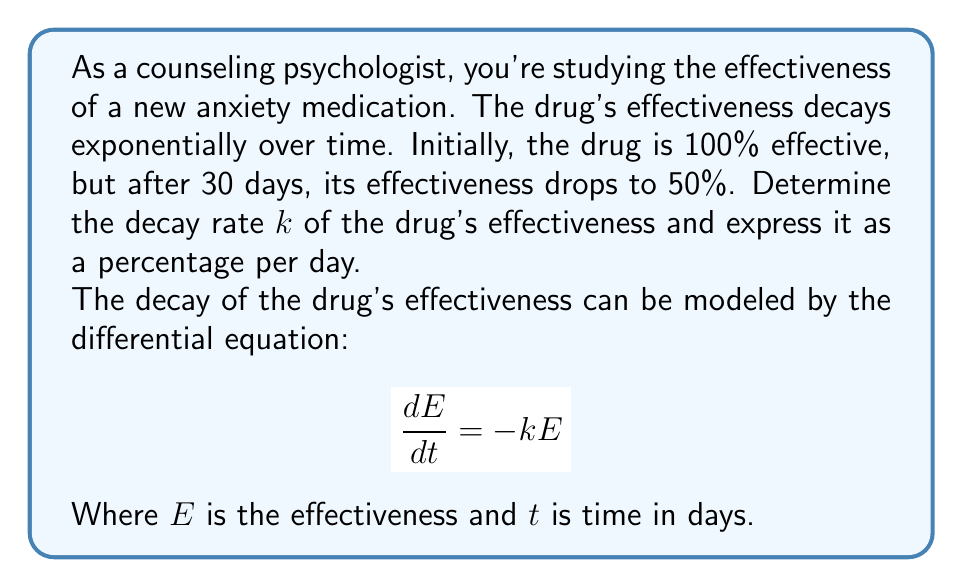Teach me how to tackle this problem. Let's solve this step-by-step:

1) The general solution to the differential equation $\frac{dE}{dt} = -kE$ is:
   
   $$E(t) = E_0e^{-kt}$$

   Where $E_0$ is the initial effectiveness.

2) We know that initially, the drug is 100% effective, so $E_0 = 100$.

3) After 30 days, the effectiveness is 50%, so we can write:

   $$50 = 100e^{-k(30)}$$

4) Dividing both sides by 100:

   $$0.5 = e^{-30k}$$

5) Taking the natural logarithm of both sides:

   $$\ln(0.5) = -30k$$

6) Solving for $k$:

   $$k = -\frac{\ln(0.5)}{30} \approx 0.0231$$

7) To express this as a percentage per day, we multiply by 100:

   $$k \approx 0.0231 \times 100 = 2.31\% \text{ per day}$$

Thus, the drug's effectiveness decays at a rate of approximately 2.31% per day.
Answer: $2.31\%$ per day 